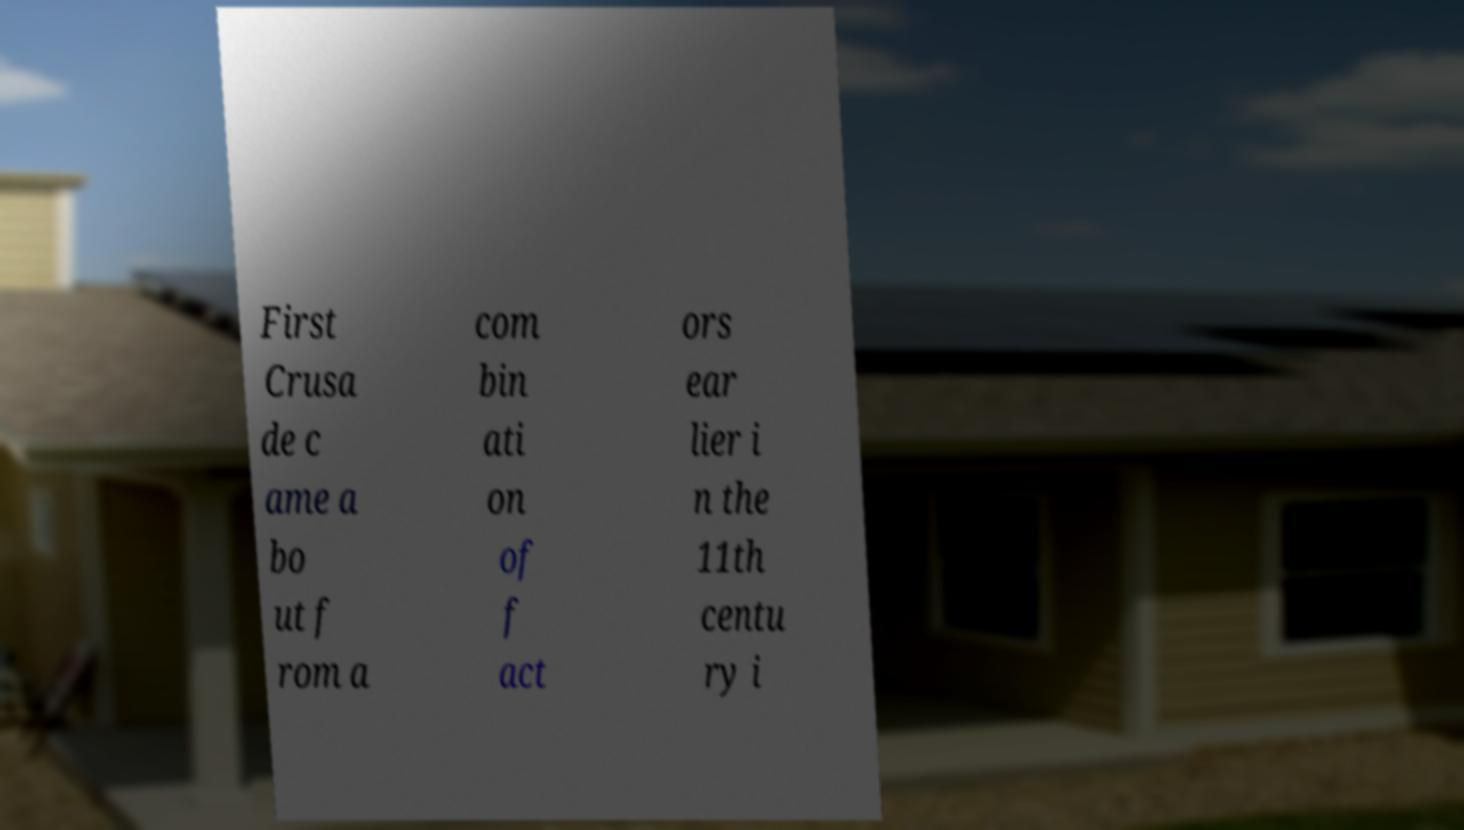For documentation purposes, I need the text within this image transcribed. Could you provide that? First Crusa de c ame a bo ut f rom a com bin ati on of f act ors ear lier i n the 11th centu ry i 